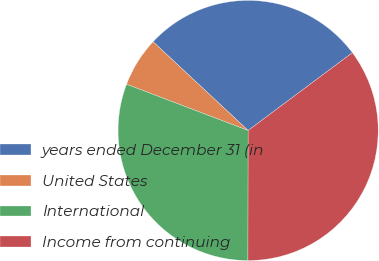Convert chart to OTSL. <chart><loc_0><loc_0><loc_500><loc_500><pie_chart><fcel>years ended December 31 (in<fcel>United States<fcel>International<fcel>Income from continuing<nl><fcel>27.85%<fcel>6.17%<fcel>30.76%<fcel>35.22%<nl></chart> 